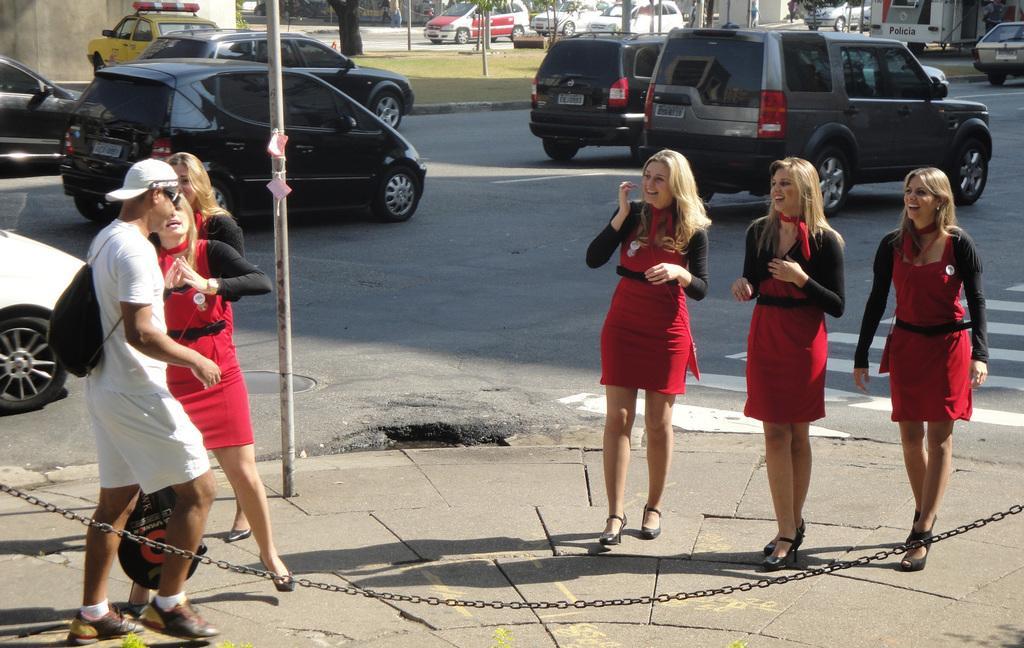Could you give a brief overview of what you see in this image? In this image I can see few women wearing red and black colored dresses are standing on the sidewalk and a person wearing white colored dress and black colored bag is standing. I can see a metal pole. In the background I can see the road, few vehicles on the road, few trees, few poles and few other objects. 